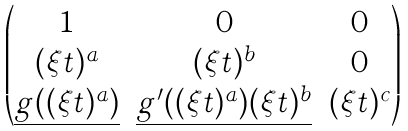<formula> <loc_0><loc_0><loc_500><loc_500>\begin{pmatrix} 1 & 0 & 0 \\ ( \xi t ) ^ { a } & ( \xi t ) ^ { b } & 0 \\ \underline { g ( ( \xi t ) ^ { a } ) } & \underline { g ^ { \prime } ( ( \xi t ) ^ { a } ) ( \xi t ) ^ { b } } & ( \xi t ) ^ { c } \end{pmatrix}</formula> 